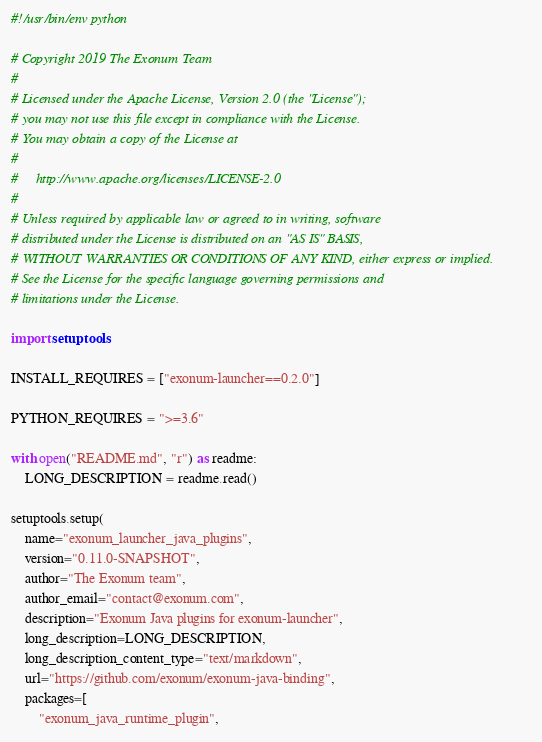Convert code to text. <code><loc_0><loc_0><loc_500><loc_500><_Python_>#!/usr/bin/env python

# Copyright 2019 The Exonum Team
#
# Licensed under the Apache License, Version 2.0 (the "License");
# you may not use this file except in compliance with the License.
# You may obtain a copy of the License at
#
#     http://www.apache.org/licenses/LICENSE-2.0
#
# Unless required by applicable law or agreed to in writing, software
# distributed under the License is distributed on an "AS IS" BASIS,
# WITHOUT WARRANTIES OR CONDITIONS OF ANY KIND, either express or implied.
# See the License for the specific language governing permissions and
# limitations under the License.

import setuptools

INSTALL_REQUIRES = ["exonum-launcher==0.2.0"]

PYTHON_REQUIRES = ">=3.6"

with open("README.md", "r") as readme:
    LONG_DESCRIPTION = readme.read()

setuptools.setup(
    name="exonum_launcher_java_plugins",
    version="0.11.0-SNAPSHOT",
    author="The Exonum team",
    author_email="contact@exonum.com",
    description="Exonum Java plugins for exonum-launcher",
    long_description=LONG_DESCRIPTION,
    long_description_content_type="text/markdown",
    url="https://github.com/exonum/exonum-java-binding",
    packages=[
        "exonum_java_runtime_plugin",</code> 